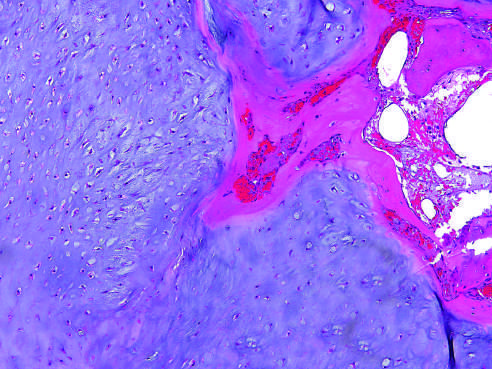what is encased by a thin layer of reactive bone?
Answer the question using a single word or phrase. A nodule of hyaline cartilage 